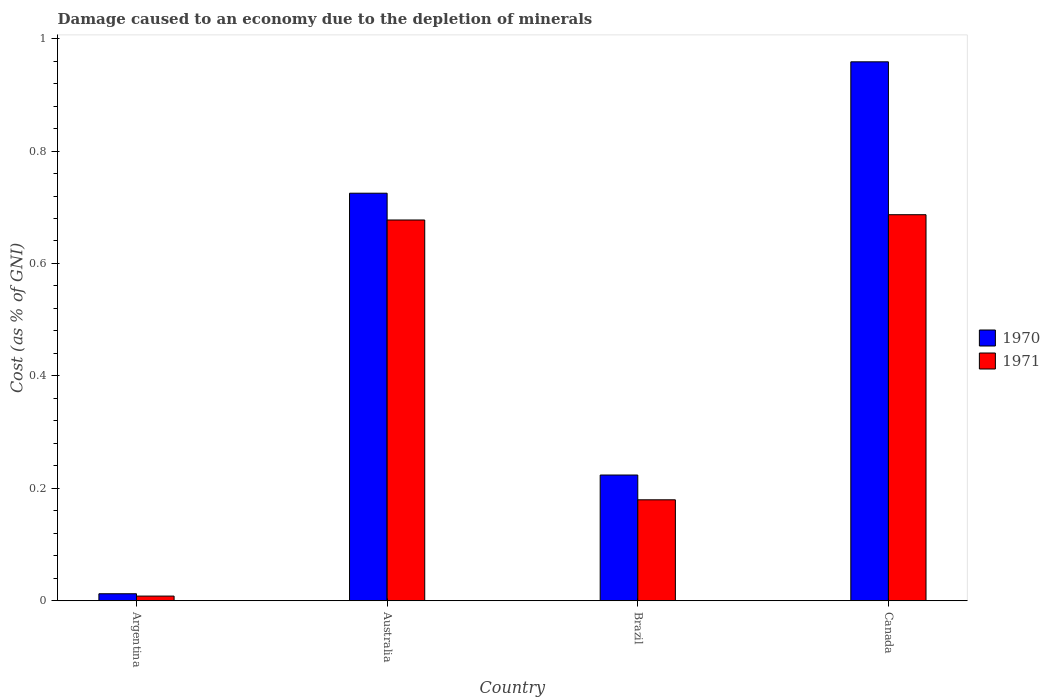How many bars are there on the 4th tick from the left?
Your answer should be very brief. 2. How many bars are there on the 1st tick from the right?
Offer a very short reply. 2. What is the label of the 4th group of bars from the left?
Your response must be concise. Canada. What is the cost of damage caused due to the depletion of minerals in 1971 in Brazil?
Your answer should be very brief. 0.18. Across all countries, what is the maximum cost of damage caused due to the depletion of minerals in 1970?
Give a very brief answer. 0.96. Across all countries, what is the minimum cost of damage caused due to the depletion of minerals in 1970?
Your answer should be compact. 0.01. In which country was the cost of damage caused due to the depletion of minerals in 1971 maximum?
Your answer should be compact. Canada. What is the total cost of damage caused due to the depletion of minerals in 1970 in the graph?
Keep it short and to the point. 1.92. What is the difference between the cost of damage caused due to the depletion of minerals in 1970 in Australia and that in Brazil?
Offer a very short reply. 0.5. What is the difference between the cost of damage caused due to the depletion of minerals in 1971 in Argentina and the cost of damage caused due to the depletion of minerals in 1970 in Canada?
Give a very brief answer. -0.95. What is the average cost of damage caused due to the depletion of minerals in 1970 per country?
Offer a terse response. 0.48. What is the difference between the cost of damage caused due to the depletion of minerals of/in 1970 and cost of damage caused due to the depletion of minerals of/in 1971 in Argentina?
Make the answer very short. 0. What is the ratio of the cost of damage caused due to the depletion of minerals in 1971 in Argentina to that in Canada?
Ensure brevity in your answer.  0.01. What is the difference between the highest and the second highest cost of damage caused due to the depletion of minerals in 1970?
Make the answer very short. 0.23. What is the difference between the highest and the lowest cost of damage caused due to the depletion of minerals in 1971?
Keep it short and to the point. 0.68. In how many countries, is the cost of damage caused due to the depletion of minerals in 1971 greater than the average cost of damage caused due to the depletion of minerals in 1971 taken over all countries?
Your response must be concise. 2. How many bars are there?
Give a very brief answer. 8. Are all the bars in the graph horizontal?
Give a very brief answer. No. Are the values on the major ticks of Y-axis written in scientific E-notation?
Your answer should be very brief. No. Does the graph contain any zero values?
Your response must be concise. No. Does the graph contain grids?
Ensure brevity in your answer.  No. What is the title of the graph?
Provide a succinct answer. Damage caused to an economy due to the depletion of minerals. What is the label or title of the Y-axis?
Provide a succinct answer. Cost (as % of GNI). What is the Cost (as % of GNI) in 1970 in Argentina?
Your answer should be compact. 0.01. What is the Cost (as % of GNI) in 1971 in Argentina?
Your answer should be compact. 0.01. What is the Cost (as % of GNI) in 1970 in Australia?
Your answer should be very brief. 0.72. What is the Cost (as % of GNI) in 1971 in Australia?
Ensure brevity in your answer.  0.68. What is the Cost (as % of GNI) in 1970 in Brazil?
Make the answer very short. 0.22. What is the Cost (as % of GNI) of 1971 in Brazil?
Provide a succinct answer. 0.18. What is the Cost (as % of GNI) in 1970 in Canada?
Give a very brief answer. 0.96. What is the Cost (as % of GNI) of 1971 in Canada?
Offer a very short reply. 0.69. Across all countries, what is the maximum Cost (as % of GNI) of 1970?
Provide a short and direct response. 0.96. Across all countries, what is the maximum Cost (as % of GNI) in 1971?
Your answer should be compact. 0.69. Across all countries, what is the minimum Cost (as % of GNI) of 1970?
Your response must be concise. 0.01. Across all countries, what is the minimum Cost (as % of GNI) of 1971?
Your answer should be compact. 0.01. What is the total Cost (as % of GNI) in 1970 in the graph?
Provide a short and direct response. 1.92. What is the total Cost (as % of GNI) in 1971 in the graph?
Provide a short and direct response. 1.55. What is the difference between the Cost (as % of GNI) in 1970 in Argentina and that in Australia?
Ensure brevity in your answer.  -0.71. What is the difference between the Cost (as % of GNI) of 1971 in Argentina and that in Australia?
Your answer should be very brief. -0.67. What is the difference between the Cost (as % of GNI) in 1970 in Argentina and that in Brazil?
Offer a very short reply. -0.21. What is the difference between the Cost (as % of GNI) in 1971 in Argentina and that in Brazil?
Offer a terse response. -0.17. What is the difference between the Cost (as % of GNI) in 1970 in Argentina and that in Canada?
Provide a short and direct response. -0.95. What is the difference between the Cost (as % of GNI) in 1971 in Argentina and that in Canada?
Provide a short and direct response. -0.68. What is the difference between the Cost (as % of GNI) of 1970 in Australia and that in Brazil?
Your response must be concise. 0.5. What is the difference between the Cost (as % of GNI) of 1971 in Australia and that in Brazil?
Offer a very short reply. 0.5. What is the difference between the Cost (as % of GNI) of 1970 in Australia and that in Canada?
Provide a succinct answer. -0.23. What is the difference between the Cost (as % of GNI) of 1971 in Australia and that in Canada?
Offer a terse response. -0.01. What is the difference between the Cost (as % of GNI) in 1970 in Brazil and that in Canada?
Provide a short and direct response. -0.73. What is the difference between the Cost (as % of GNI) in 1971 in Brazil and that in Canada?
Provide a short and direct response. -0.51. What is the difference between the Cost (as % of GNI) of 1970 in Argentina and the Cost (as % of GNI) of 1971 in Australia?
Offer a very short reply. -0.66. What is the difference between the Cost (as % of GNI) in 1970 in Argentina and the Cost (as % of GNI) in 1971 in Brazil?
Provide a succinct answer. -0.17. What is the difference between the Cost (as % of GNI) in 1970 in Argentina and the Cost (as % of GNI) in 1971 in Canada?
Make the answer very short. -0.67. What is the difference between the Cost (as % of GNI) in 1970 in Australia and the Cost (as % of GNI) in 1971 in Brazil?
Keep it short and to the point. 0.55. What is the difference between the Cost (as % of GNI) in 1970 in Australia and the Cost (as % of GNI) in 1971 in Canada?
Offer a very short reply. 0.04. What is the difference between the Cost (as % of GNI) in 1970 in Brazil and the Cost (as % of GNI) in 1971 in Canada?
Keep it short and to the point. -0.46. What is the average Cost (as % of GNI) of 1970 per country?
Your answer should be very brief. 0.48. What is the average Cost (as % of GNI) of 1971 per country?
Your answer should be very brief. 0.39. What is the difference between the Cost (as % of GNI) in 1970 and Cost (as % of GNI) in 1971 in Argentina?
Offer a terse response. 0. What is the difference between the Cost (as % of GNI) of 1970 and Cost (as % of GNI) of 1971 in Australia?
Your answer should be compact. 0.05. What is the difference between the Cost (as % of GNI) in 1970 and Cost (as % of GNI) in 1971 in Brazil?
Make the answer very short. 0.04. What is the difference between the Cost (as % of GNI) in 1970 and Cost (as % of GNI) in 1971 in Canada?
Your answer should be very brief. 0.27. What is the ratio of the Cost (as % of GNI) of 1970 in Argentina to that in Australia?
Your answer should be compact. 0.02. What is the ratio of the Cost (as % of GNI) of 1971 in Argentina to that in Australia?
Your response must be concise. 0.01. What is the ratio of the Cost (as % of GNI) in 1970 in Argentina to that in Brazil?
Give a very brief answer. 0.06. What is the ratio of the Cost (as % of GNI) of 1971 in Argentina to that in Brazil?
Your response must be concise. 0.05. What is the ratio of the Cost (as % of GNI) of 1970 in Argentina to that in Canada?
Offer a terse response. 0.01. What is the ratio of the Cost (as % of GNI) of 1971 in Argentina to that in Canada?
Provide a succinct answer. 0.01. What is the ratio of the Cost (as % of GNI) in 1970 in Australia to that in Brazil?
Offer a terse response. 3.24. What is the ratio of the Cost (as % of GNI) in 1971 in Australia to that in Brazil?
Provide a short and direct response. 3.77. What is the ratio of the Cost (as % of GNI) in 1970 in Australia to that in Canada?
Provide a succinct answer. 0.76. What is the ratio of the Cost (as % of GNI) in 1971 in Australia to that in Canada?
Your response must be concise. 0.99. What is the ratio of the Cost (as % of GNI) of 1970 in Brazil to that in Canada?
Make the answer very short. 0.23. What is the ratio of the Cost (as % of GNI) of 1971 in Brazil to that in Canada?
Keep it short and to the point. 0.26. What is the difference between the highest and the second highest Cost (as % of GNI) in 1970?
Offer a very short reply. 0.23. What is the difference between the highest and the second highest Cost (as % of GNI) of 1971?
Offer a very short reply. 0.01. What is the difference between the highest and the lowest Cost (as % of GNI) of 1970?
Your response must be concise. 0.95. What is the difference between the highest and the lowest Cost (as % of GNI) of 1971?
Give a very brief answer. 0.68. 